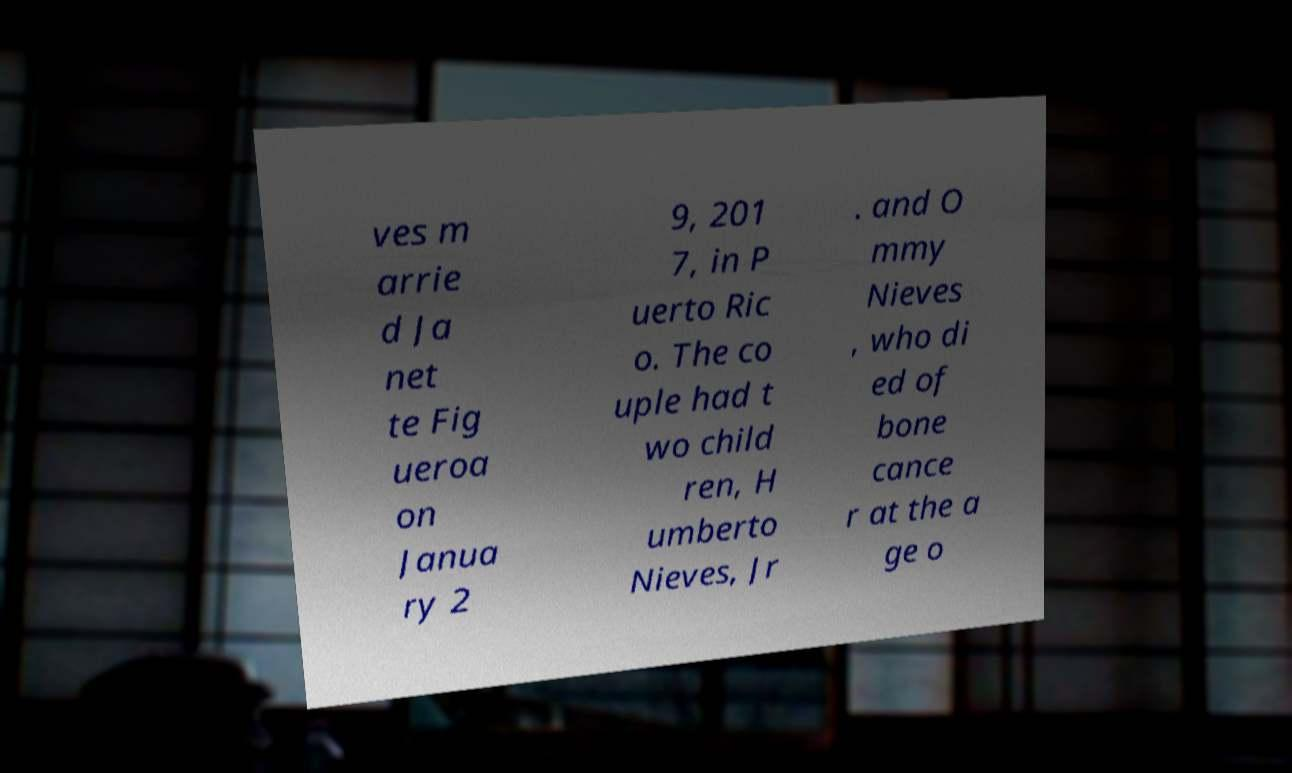Could you extract and type out the text from this image? ves m arrie d Ja net te Fig ueroa on Janua ry 2 9, 201 7, in P uerto Ric o. The co uple had t wo child ren, H umberto Nieves, Jr . and O mmy Nieves , who di ed of bone cance r at the a ge o 